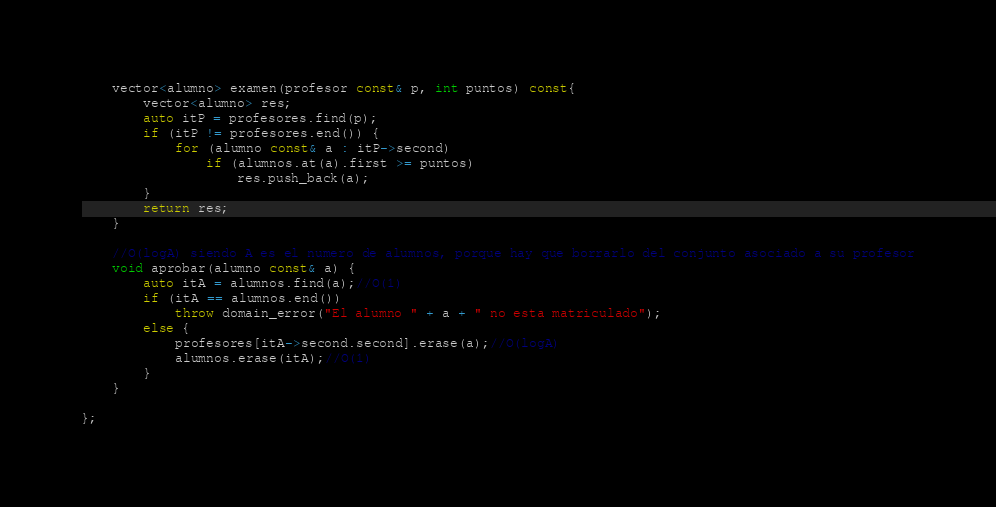Convert code to text. <code><loc_0><loc_0><loc_500><loc_500><_C++_>	vector<alumno> examen(profesor const& p, int puntos) const{
		vector<alumno> res;
		auto itP = profesores.find(p);
		if (itP != profesores.end()) {
			for (alumno const& a : itP->second)
				if (alumnos.at(a).first >= puntos)
					res.push_back(a);
		}
		return res;
	}

	//O(logA) siendo A es el numero de alumnos, porque hay que borrarlo del conjunto asociado a su profesor
	void aprobar(alumno const& a) {
		auto itA = alumnos.find(a);//O(1)
		if (itA == alumnos.end())
			throw domain_error("El alumno " + a + " no esta matriculado");
		else {
			profesores[itA->second.second].erase(a);//O(logA)
			alumnos.erase(itA);//O(1)
		}
	}

};</code> 